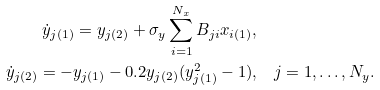<formula> <loc_0><loc_0><loc_500><loc_500>\dot { y } _ { j ( 1 ) } = y _ { j ( 2 ) } + \sigma _ { y } \sum _ { i = 1 } ^ { N _ { x } } B _ { j i } x _ { i ( 1 ) } , & \\ \dot { y } _ { j ( 2 ) } = - y _ { j ( 1 ) } - 0 . 2 y _ { j ( 2 ) } ( { y _ { j ( 1 ) } ^ { 2 } } - 1 ) , & \quad j = 1 , \dots , N _ { y } .</formula> 